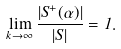<formula> <loc_0><loc_0><loc_500><loc_500>\lim _ { k \to \infty } \frac { | S ^ { + } ( \alpha ) | } { | S | } = 1 .</formula> 